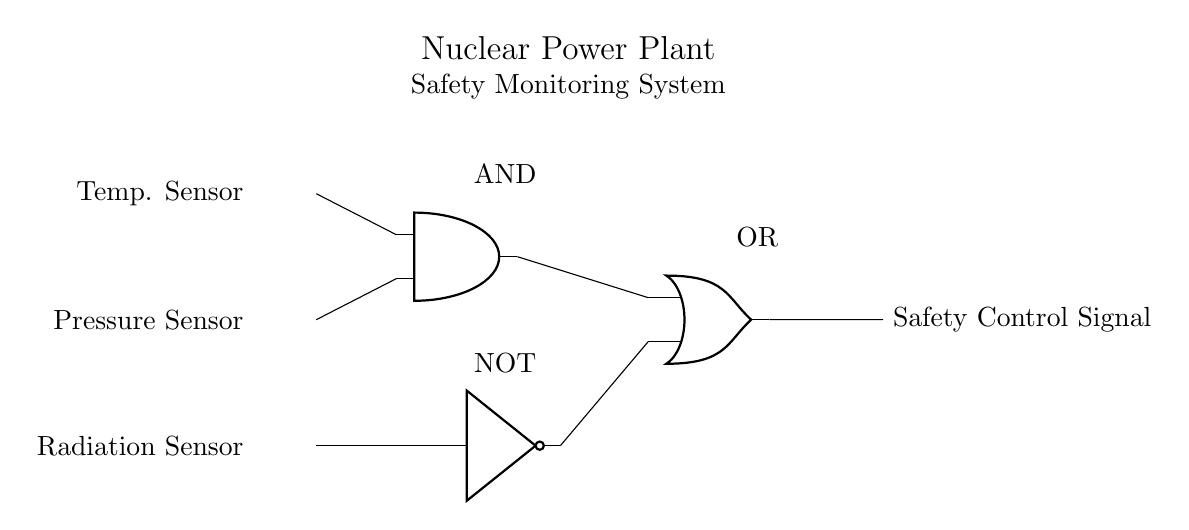What type of system is illustrated? The system is a Nuclear Power Plant Safety Monitoring System, indicated by the title at the top of the diagram.
Answer: Nuclear Power Plant Safety Monitoring System How many sensors are connected to the logic gates? There are three sensors: a temperature sensor, a pressure sensor, and a radiation sensor, as labeled on the left side of the diagram.
Answer: Three What does the AND gate output connect to? The output of the AND gate connects to the input of the OR gate, as shown by the connecting line in the diagram.
Answer: OR gate If the NOT gate receives a signal, what will its output be? The NOT gate inverts its input signal; therefore, if it receives a signal, its output will be the opposite of that input signal. For example, if it receives a high signal, it will output a low signal.
Answer: Inverted signal What is the function of the OR gate in this circuit? The OR gate receives the outputs from both the AND gate and the NOT gate, allowing it to output a safety control signal if either input is high, serving to enhance safety under varying conditions.
Answer: Combine signals What happens to the safety control signal if both the AND gate's inputs are low? If both inputs to the AND gate are low, the output of the AND gate is also low, which will lead to the NOT gate inverting the signal to high and inputting it to the OR gate. Consequently, the safety control signal will be high indicating a potential safety issue requiring attention.
Answer: High signal 